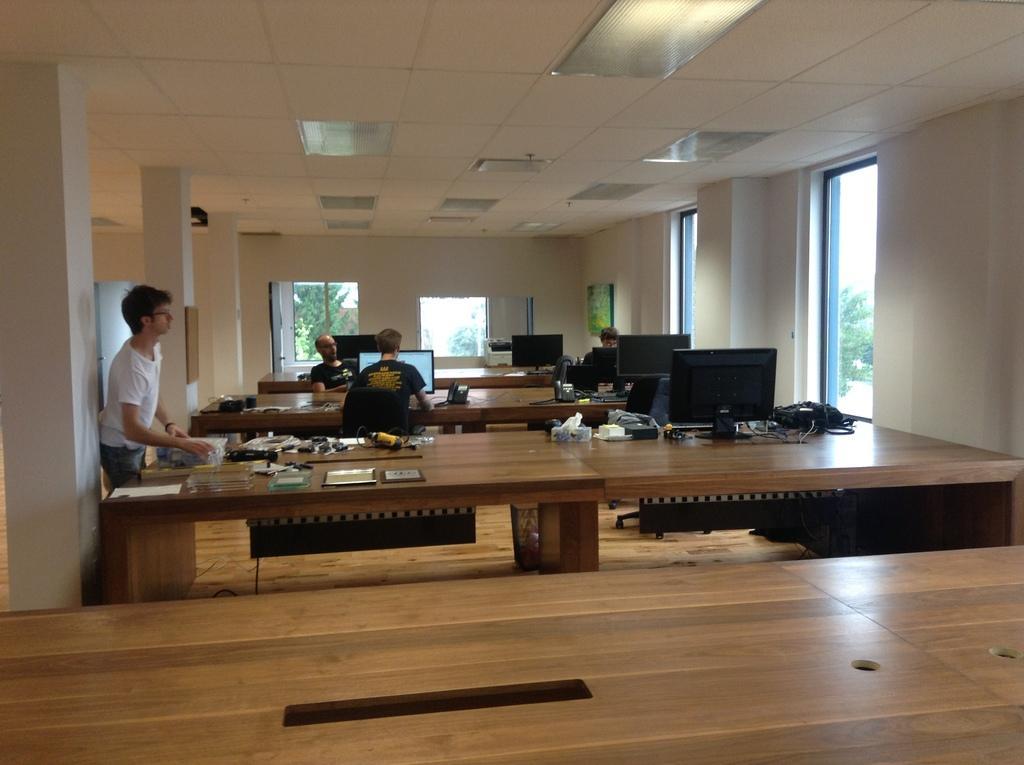Can you describe this image briefly? In this picture there are some members sitting in the chairs in front of a computer which was placed on the table. There is a guy in the left side standing. There are some empty tables. In the background there is window, wall and a pillar. 